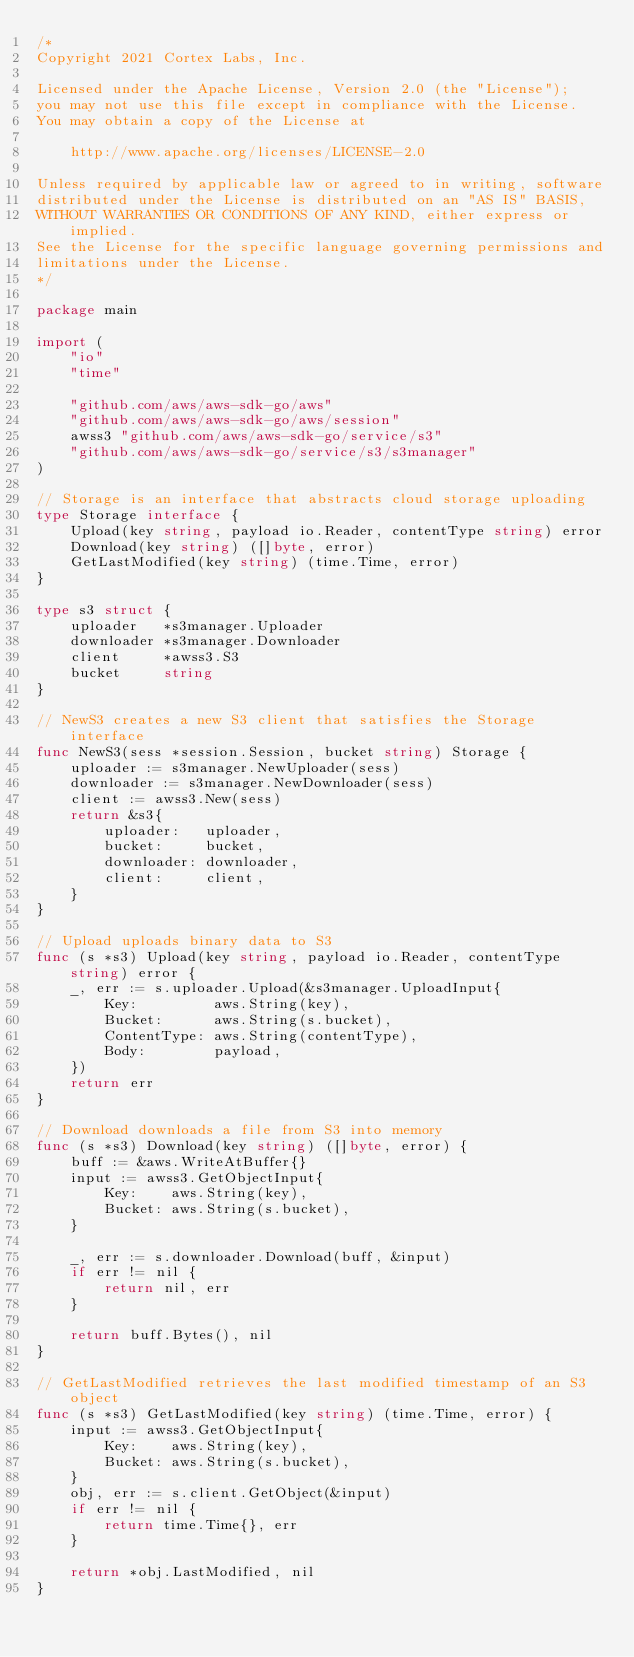Convert code to text. <code><loc_0><loc_0><loc_500><loc_500><_Go_>/*
Copyright 2021 Cortex Labs, Inc.

Licensed under the Apache License, Version 2.0 (the "License");
you may not use this file except in compliance with the License.
You may obtain a copy of the License at

    http://www.apache.org/licenses/LICENSE-2.0

Unless required by applicable law or agreed to in writing, software
distributed under the License is distributed on an "AS IS" BASIS,
WITHOUT WARRANTIES OR CONDITIONS OF ANY KIND, either express or implied.
See the License for the specific language governing permissions and
limitations under the License.
*/

package main

import (
	"io"
	"time"

	"github.com/aws/aws-sdk-go/aws"
	"github.com/aws/aws-sdk-go/aws/session"
	awss3 "github.com/aws/aws-sdk-go/service/s3"
	"github.com/aws/aws-sdk-go/service/s3/s3manager"
)

// Storage is an interface that abstracts cloud storage uploading
type Storage interface {
	Upload(key string, payload io.Reader, contentType string) error
	Download(key string) ([]byte, error)
	GetLastModified(key string) (time.Time, error)
}

type s3 struct {
	uploader   *s3manager.Uploader
	downloader *s3manager.Downloader
	client     *awss3.S3
	bucket     string
}

// NewS3 creates a new S3 client that satisfies the Storage interface
func NewS3(sess *session.Session, bucket string) Storage {
	uploader := s3manager.NewUploader(sess)
	downloader := s3manager.NewDownloader(sess)
	client := awss3.New(sess)
	return &s3{
		uploader:   uploader,
		bucket:     bucket,
		downloader: downloader,
		client:     client,
	}
}

// Upload uploads binary data to S3
func (s *s3) Upload(key string, payload io.Reader, contentType string) error {
	_, err := s.uploader.Upload(&s3manager.UploadInput{
		Key:         aws.String(key),
		Bucket:      aws.String(s.bucket),
		ContentType: aws.String(contentType),
		Body:        payload,
	})
	return err
}

// Download downloads a file from S3 into memory
func (s *s3) Download(key string) ([]byte, error) {
	buff := &aws.WriteAtBuffer{}
	input := awss3.GetObjectInput{
		Key:    aws.String(key),
		Bucket: aws.String(s.bucket),
	}

	_, err := s.downloader.Download(buff, &input)
	if err != nil {
		return nil, err
	}

	return buff.Bytes(), nil
}

// GetLastModified retrieves the last modified timestamp of an S3 object
func (s *s3) GetLastModified(key string) (time.Time, error) {
	input := awss3.GetObjectInput{
		Key:    aws.String(key),
		Bucket: aws.String(s.bucket),
	}
	obj, err := s.client.GetObject(&input)
	if err != nil {
		return time.Time{}, err
	}

	return *obj.LastModified, nil
}
</code> 